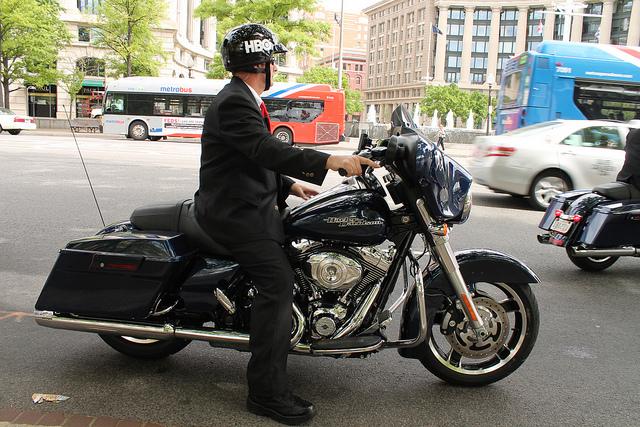What is written on the side of the man's helmet?
Short answer required. Hbo. How many cars are there?
Keep it brief. 2. What color is the helmet?
Answer briefly. Black. 